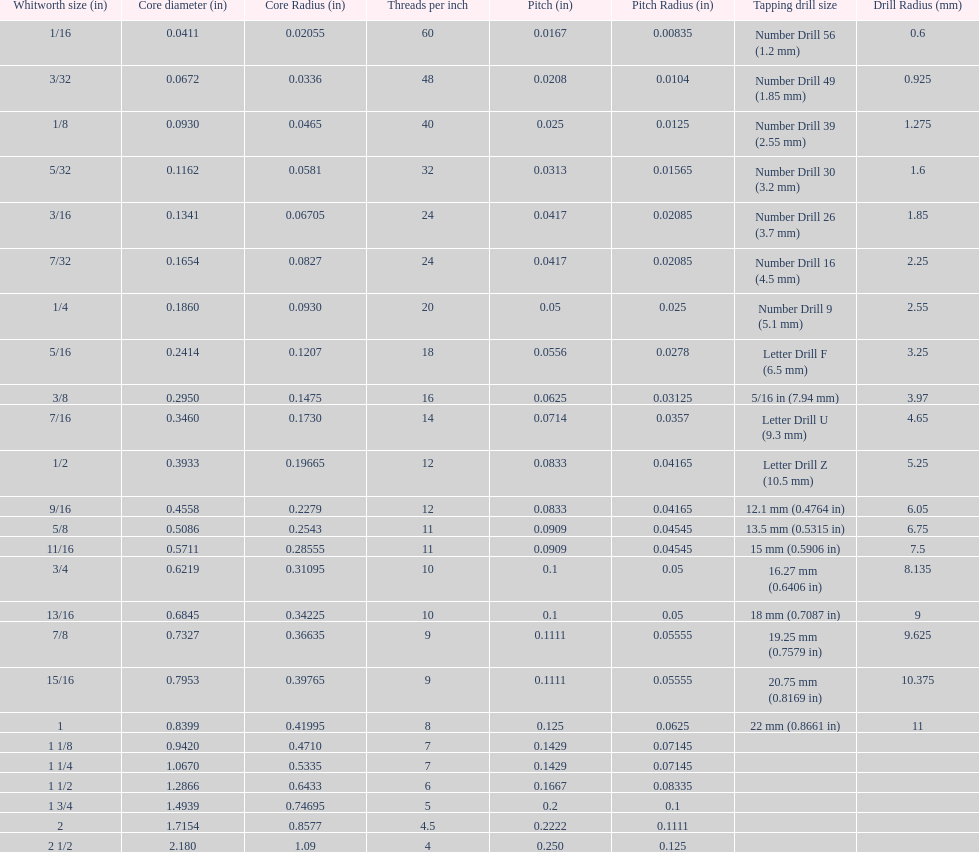What core diameter (in) comes after 0.0930? 0.1162. 